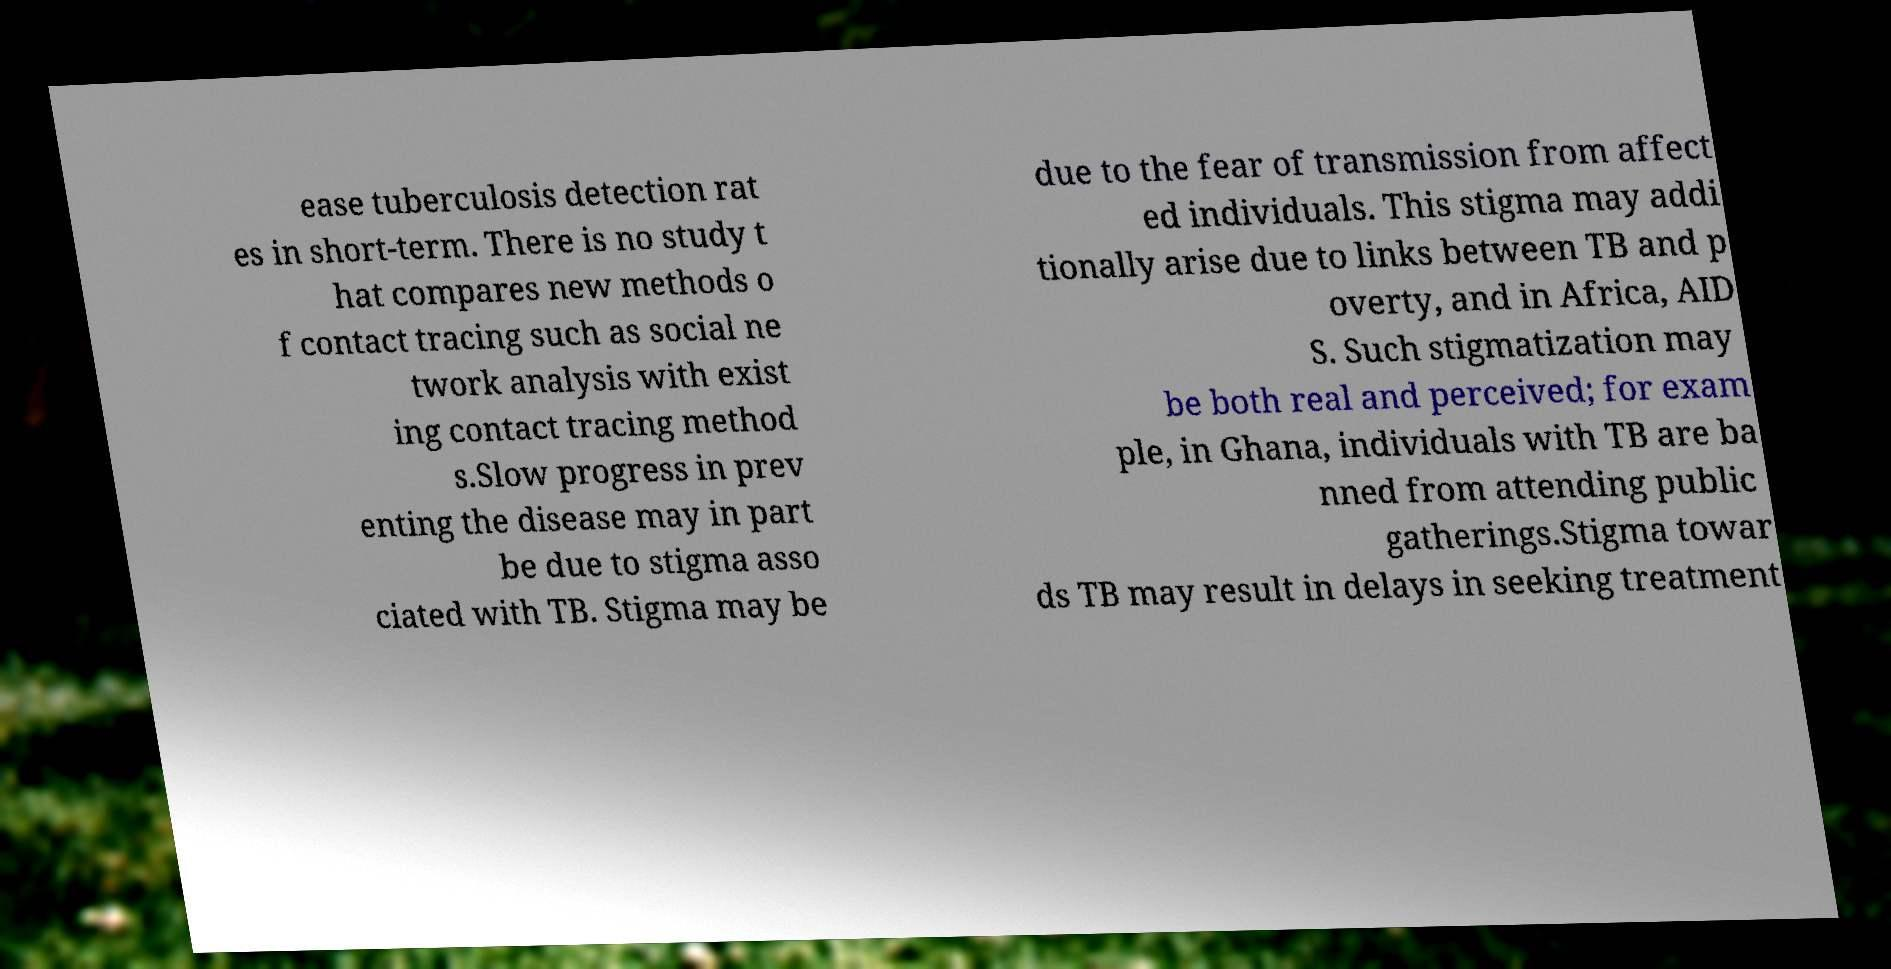For documentation purposes, I need the text within this image transcribed. Could you provide that? ease tuberculosis detection rat es in short-term. There is no study t hat compares new methods o f contact tracing such as social ne twork analysis with exist ing contact tracing method s.Slow progress in prev enting the disease may in part be due to stigma asso ciated with TB. Stigma may be due to the fear of transmission from affect ed individuals. This stigma may addi tionally arise due to links between TB and p overty, and in Africa, AID S. Such stigmatization may be both real and perceived; for exam ple, in Ghana, individuals with TB are ba nned from attending public gatherings.Stigma towar ds TB may result in delays in seeking treatment 